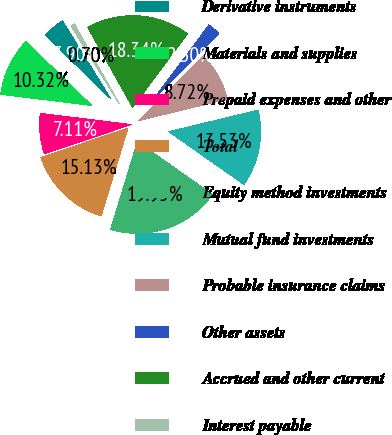Convert chart to OTSL. <chart><loc_0><loc_0><loc_500><loc_500><pie_chart><fcel>Derivative instruments<fcel>Materials and supplies<fcel>Prepaid expenses and other<fcel>Total<fcel>Equity method investments<fcel>Mutual fund investments<fcel>Probable insurance claims<fcel>Other assets<fcel>Accrued and other current<fcel>Interest payable<nl><fcel>3.9%<fcel>10.32%<fcel>7.11%<fcel>15.13%<fcel>19.95%<fcel>13.53%<fcel>8.72%<fcel>2.3%<fcel>18.34%<fcel>0.7%<nl></chart> 